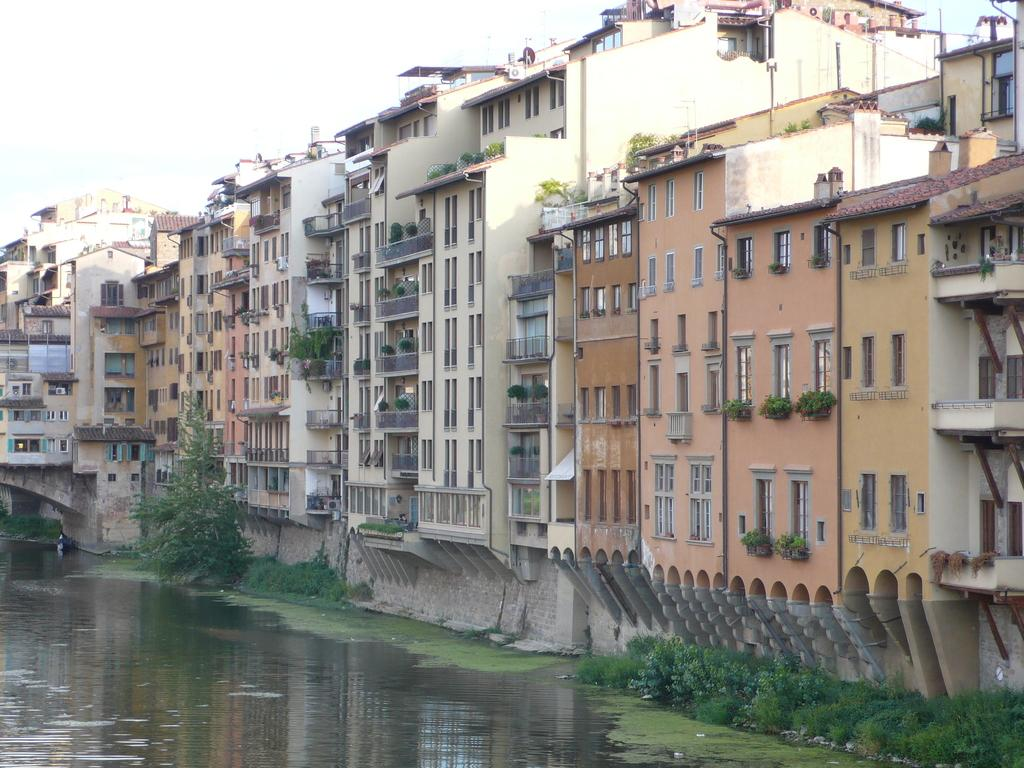What is visible in the image? Water and plants are visible in the image. What can be seen in the background of the image? There are buildings in the background of the image. How many ladybugs are crawling on the side of the butter in the image? There are no ladybugs or butter present in the image. 